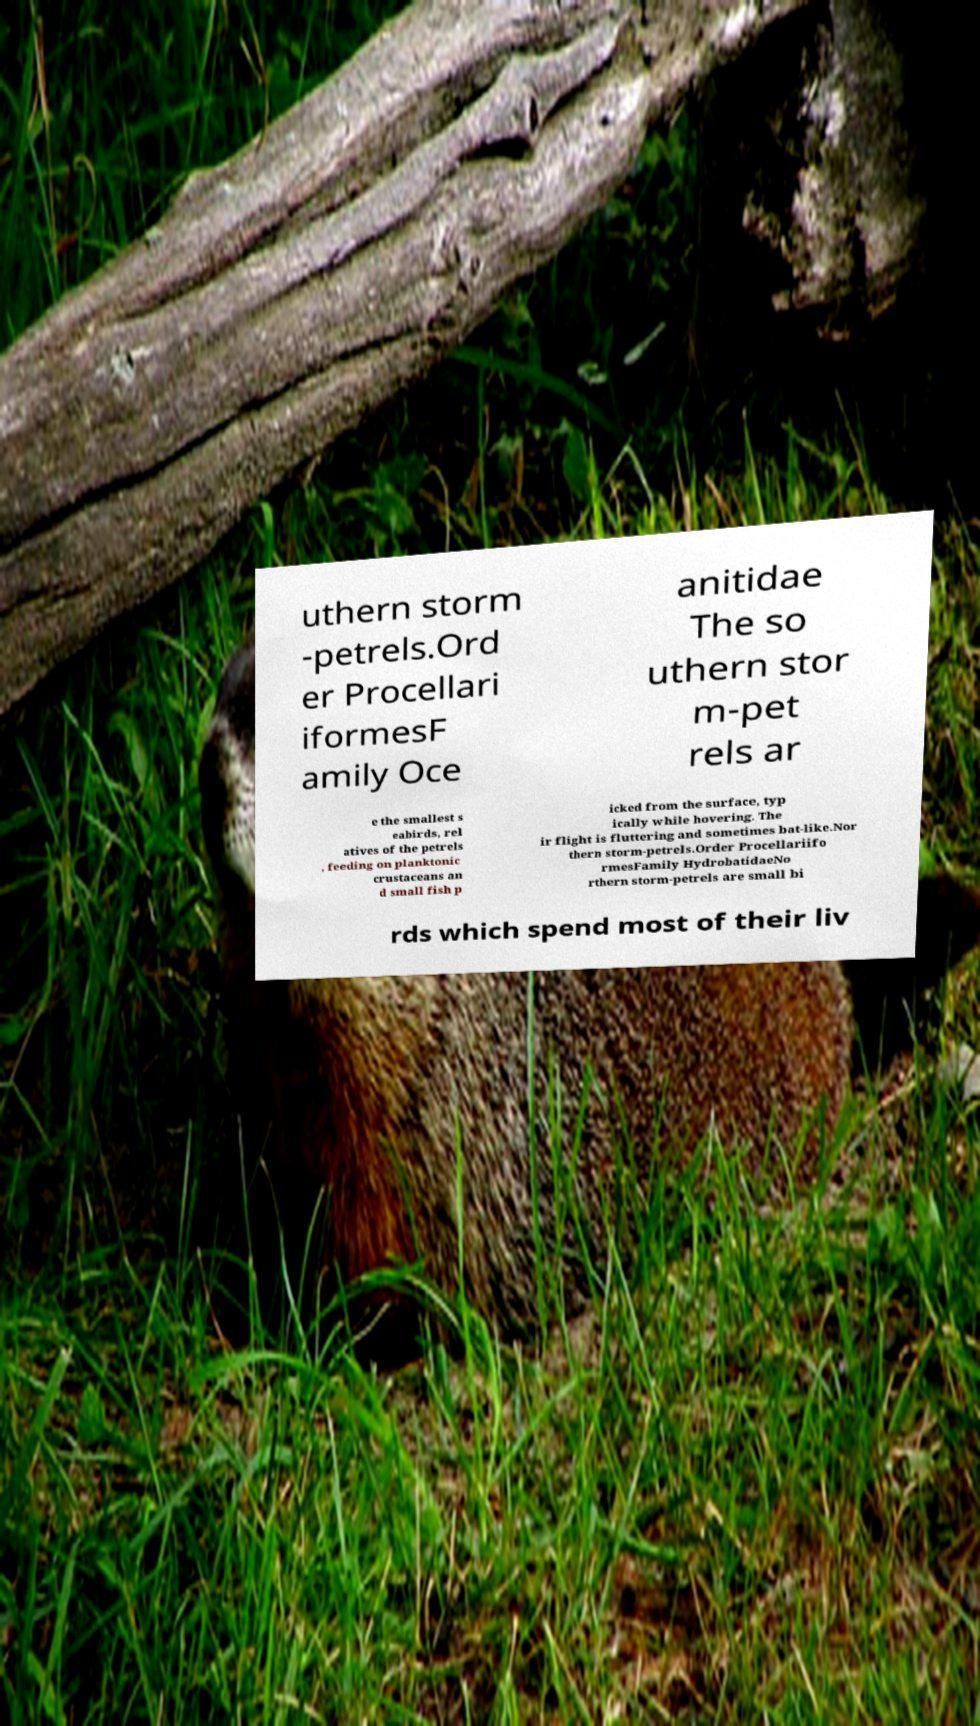Can you read and provide the text displayed in the image?This photo seems to have some interesting text. Can you extract and type it out for me? uthern storm -petrels.Ord er Procellari iformesF amily Oce anitidae The so uthern stor m-pet rels ar e the smallest s eabirds, rel atives of the petrels , feeding on planktonic crustaceans an d small fish p icked from the surface, typ ically while hovering. The ir flight is fluttering and sometimes bat-like.Nor thern storm-petrels.Order Procellariifo rmesFamily HydrobatidaeNo rthern storm-petrels are small bi rds which spend most of their liv 